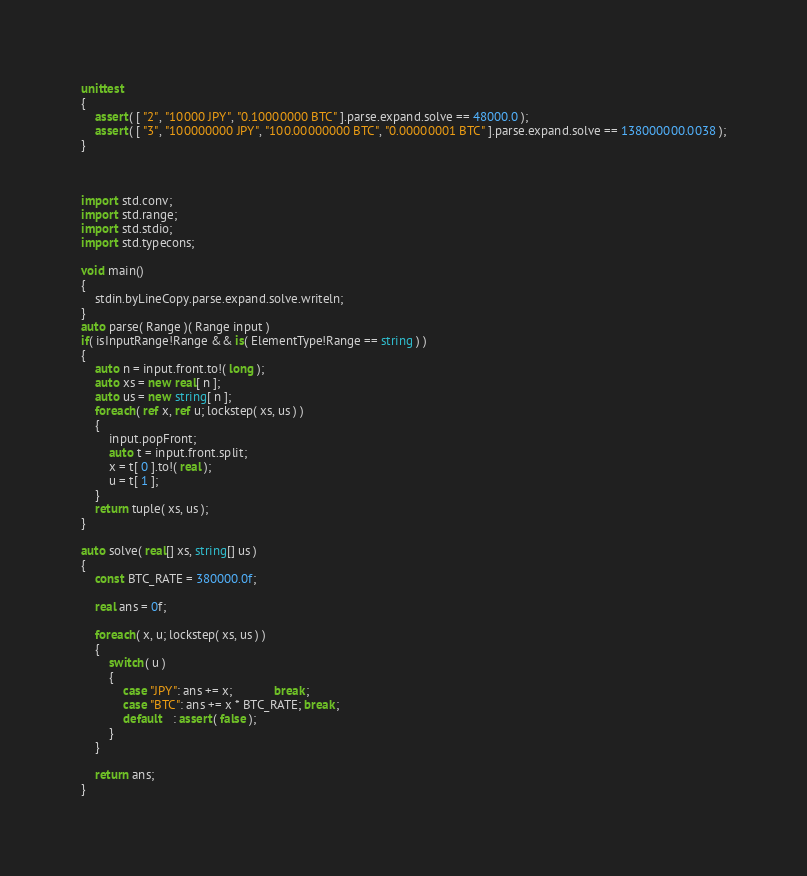<code> <loc_0><loc_0><loc_500><loc_500><_D_>unittest
{
	assert( [ "2", "10000 JPY", "0.10000000 BTC" ].parse.expand.solve == 48000.0 );
	assert( [ "3", "100000000 JPY", "100.00000000 BTC", "0.00000001 BTC" ].parse.expand.solve == 138000000.0038 );
}



import std.conv;
import std.range;
import std.stdio;
import std.typecons;

void main()
{
	stdin.byLineCopy.parse.expand.solve.writeln;
}
auto parse( Range )( Range input )
if( isInputRange!Range && is( ElementType!Range == string ) )
{
	auto n = input.front.to!( long );
	auto xs = new real[ n ];
	auto us = new string[ n ];
	foreach( ref x, ref u; lockstep( xs, us ) )
	{
		input.popFront;
		auto t = input.front.split;
		x = t[ 0 ].to!( real );
		u = t[ 1 ];
	}
	return tuple( xs, us );
}

auto solve( real[] xs, string[] us )
{
	const BTC_RATE = 380000.0f;
	
	real ans = 0f;
	
	foreach( x, u; lockstep( xs, us ) )
	{
		switch( u )
		{
			case "JPY": ans += x;            break;
			case "BTC": ans += x * BTC_RATE; break;
			default   : assert( false );
		}
	}
	
	return ans;
}
</code> 